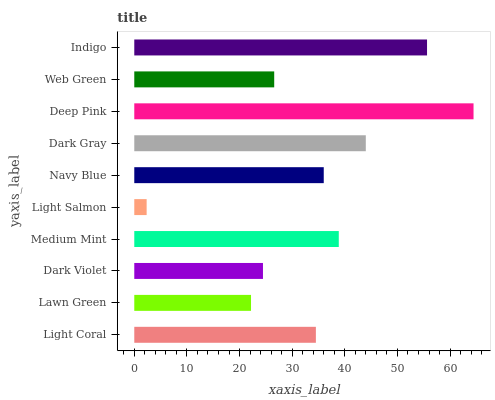Is Light Salmon the minimum?
Answer yes or no. Yes. Is Deep Pink the maximum?
Answer yes or no. Yes. Is Lawn Green the minimum?
Answer yes or no. No. Is Lawn Green the maximum?
Answer yes or no. No. Is Light Coral greater than Lawn Green?
Answer yes or no. Yes. Is Lawn Green less than Light Coral?
Answer yes or no. Yes. Is Lawn Green greater than Light Coral?
Answer yes or no. No. Is Light Coral less than Lawn Green?
Answer yes or no. No. Is Navy Blue the high median?
Answer yes or no. Yes. Is Light Coral the low median?
Answer yes or no. Yes. Is Dark Gray the high median?
Answer yes or no. No. Is Light Salmon the low median?
Answer yes or no. No. 